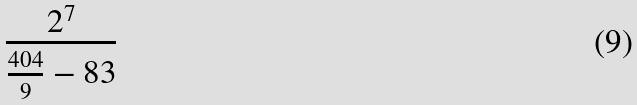Convert formula to latex. <formula><loc_0><loc_0><loc_500><loc_500>\frac { 2 ^ { 7 } } { \frac { 4 0 4 } { 9 } - 8 3 }</formula> 